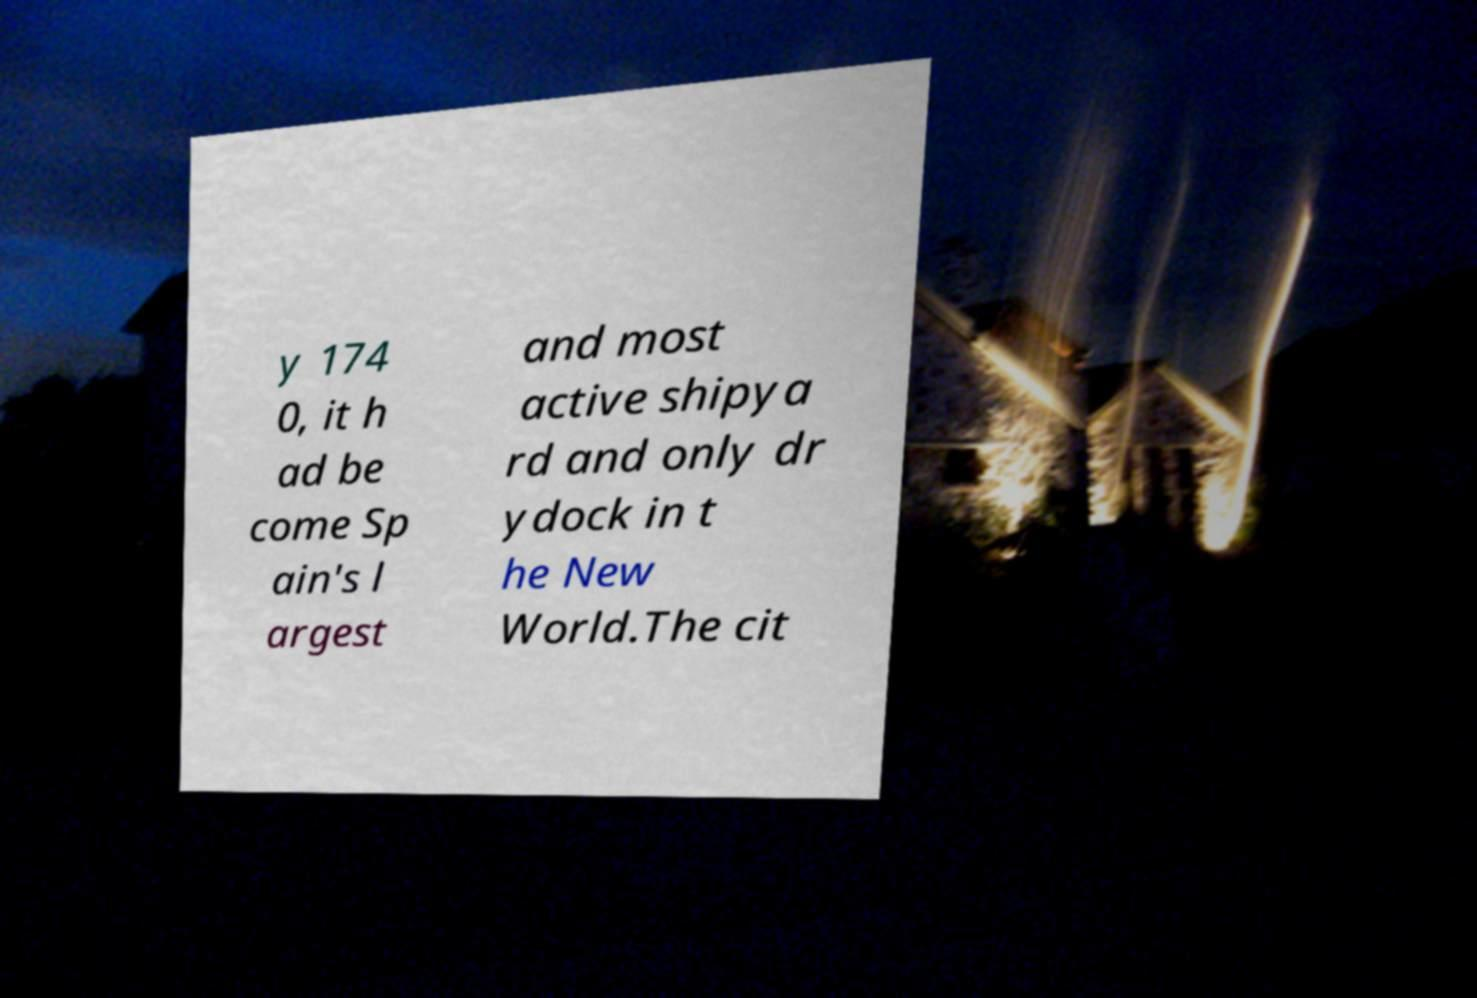Please read and relay the text visible in this image. What does it say? y 174 0, it h ad be come Sp ain's l argest and most active shipya rd and only dr ydock in t he New World.The cit 